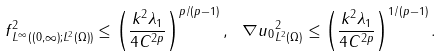Convert formula to latex. <formula><loc_0><loc_0><loc_500><loc_500>\| f \| ^ { 2 } _ { L ^ { \infty } ( ( 0 , \infty ) ; L ^ { 2 } ( \Omega ) ) } \leq \left ( \frac { k ^ { 2 } \lambda _ { 1 } } { 4 C ^ { 2 p } } \right ) ^ { p / ( p - 1 ) } , \ \| \nabla u _ { 0 } \| ^ { 2 } _ { L ^ { 2 } ( \Omega ) } \leq \left ( \frac { k ^ { 2 } \lambda _ { 1 } } { 4 C ^ { 2 p } } \right ) ^ { 1 / ( p - 1 ) } .</formula> 